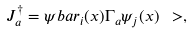<formula> <loc_0><loc_0><loc_500><loc_500>J ^ { \dag } _ { a } = \psi b a r _ { i } ( x ) \Gamma _ { a } \psi _ { j } ( x ) \ > ,</formula> 